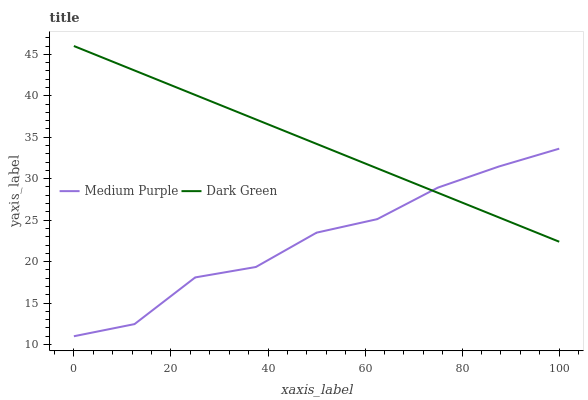Does Medium Purple have the minimum area under the curve?
Answer yes or no. Yes. Does Dark Green have the maximum area under the curve?
Answer yes or no. Yes. Does Dark Green have the minimum area under the curve?
Answer yes or no. No. Is Dark Green the smoothest?
Answer yes or no. Yes. Is Medium Purple the roughest?
Answer yes or no. Yes. Is Dark Green the roughest?
Answer yes or no. No. Does Medium Purple have the lowest value?
Answer yes or no. Yes. Does Dark Green have the lowest value?
Answer yes or no. No. Does Dark Green have the highest value?
Answer yes or no. Yes. Does Medium Purple intersect Dark Green?
Answer yes or no. Yes. Is Medium Purple less than Dark Green?
Answer yes or no. No. Is Medium Purple greater than Dark Green?
Answer yes or no. No. 